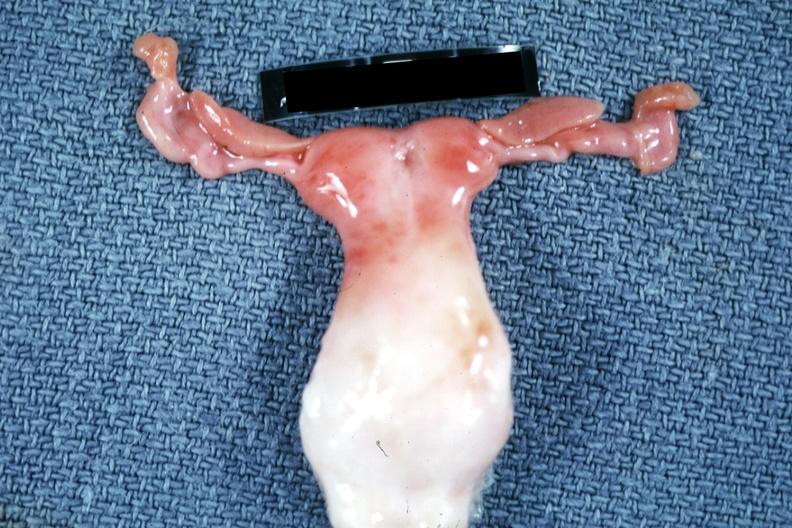s yo present?
Answer the question using a single word or phrase. No 